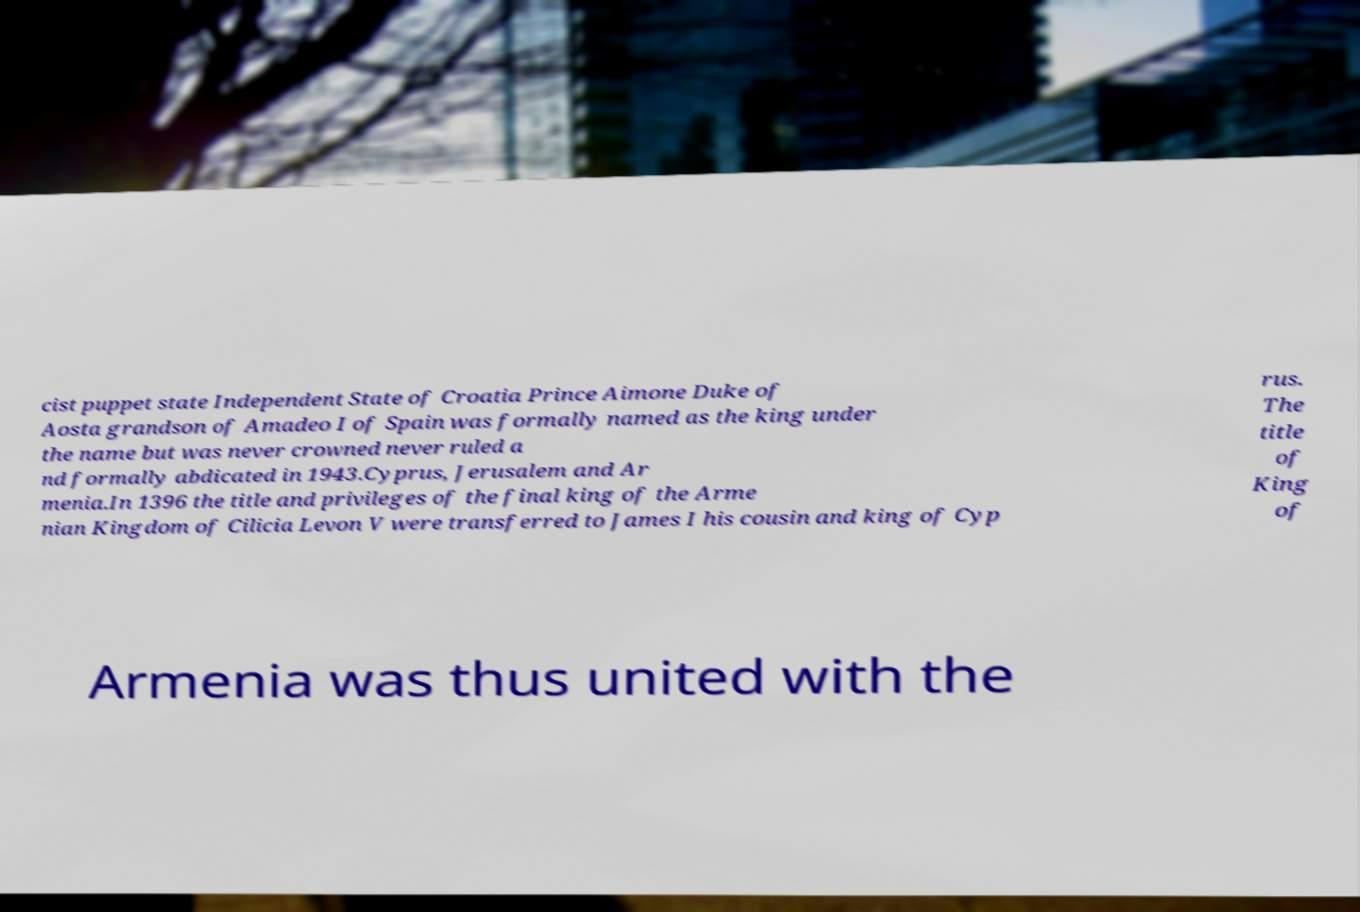For documentation purposes, I need the text within this image transcribed. Could you provide that? cist puppet state Independent State of Croatia Prince Aimone Duke of Aosta grandson of Amadeo I of Spain was formally named as the king under the name but was never crowned never ruled a nd formally abdicated in 1943.Cyprus, Jerusalem and Ar menia.In 1396 the title and privileges of the final king of the Arme nian Kingdom of Cilicia Levon V were transferred to James I his cousin and king of Cyp rus. The title of King of Armenia was thus united with the 